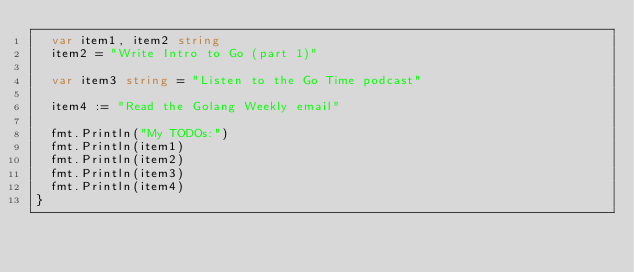<code> <loc_0><loc_0><loc_500><loc_500><_Go_>	var item1, item2 string
	item2 = "Write Intro to Go (part 1)"

	var item3 string = "Listen to the Go Time podcast"

	item4 := "Read the Golang Weekly email"

	fmt.Println("My TODOs:")
	fmt.Println(item1)
	fmt.Println(item2)
	fmt.Println(item3)
	fmt.Println(item4)
}
</code> 